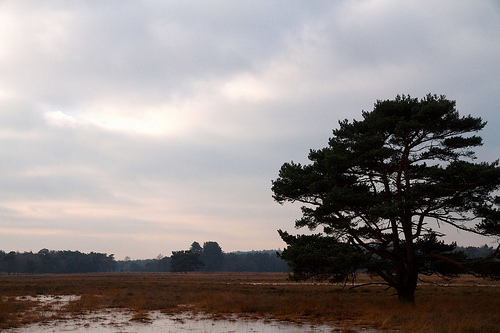<image>
Is the tree above the grass? Yes. The tree is positioned above the grass in the vertical space, higher up in the scene. 